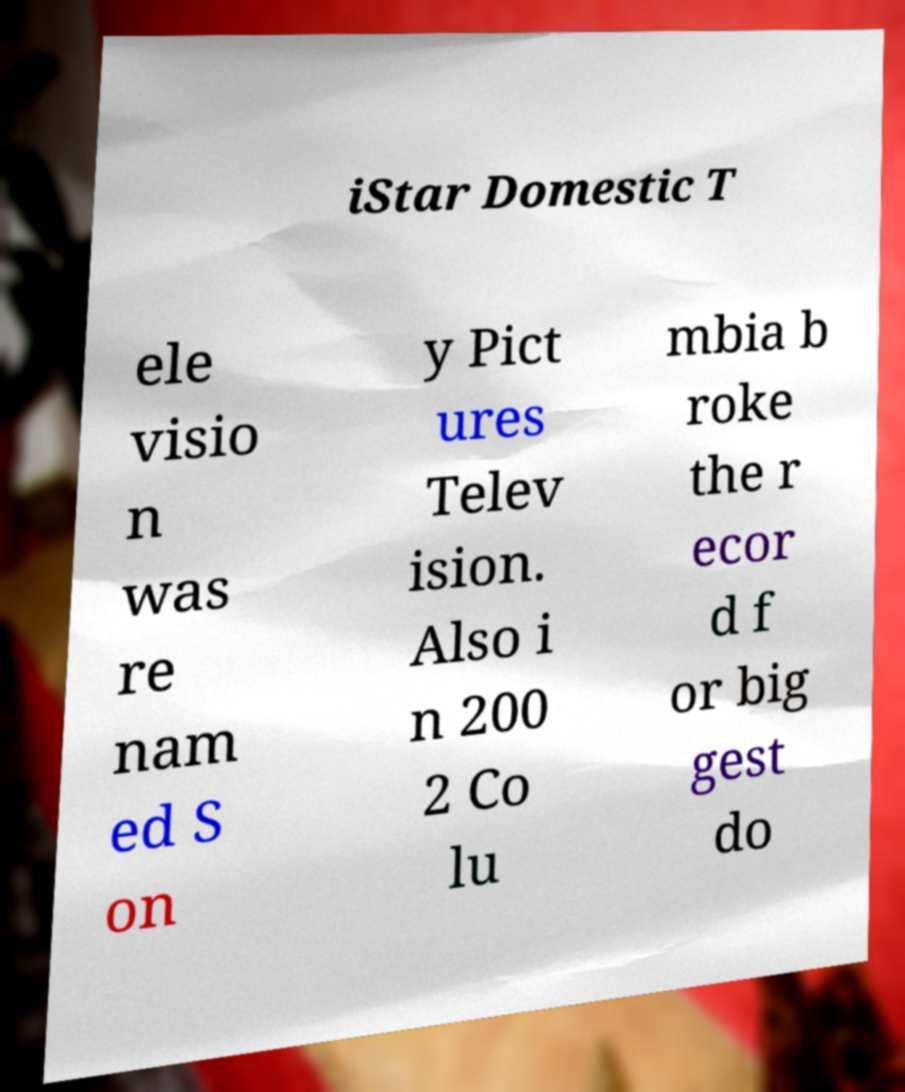Can you accurately transcribe the text from the provided image for me? iStar Domestic T ele visio n was re nam ed S on y Pict ures Telev ision. Also i n 200 2 Co lu mbia b roke the r ecor d f or big gest do 